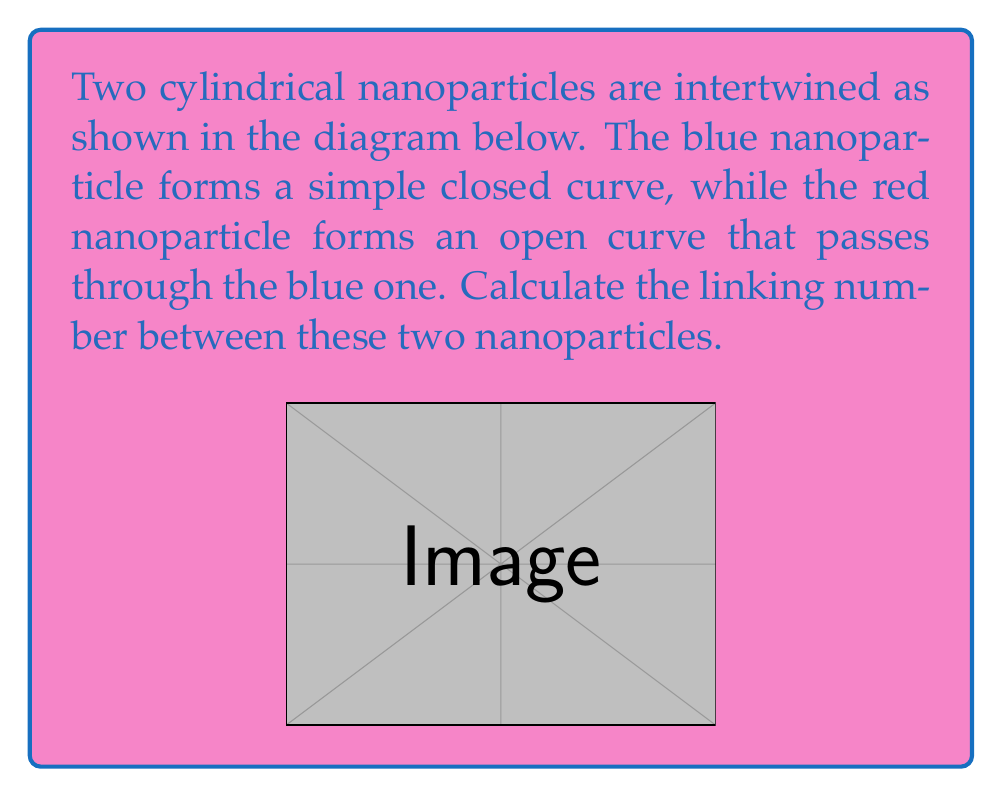Show me your answer to this math problem. To compute the linking number between two intertwined nanoparticles, we need to follow these steps:

1) The linking number is defined as half the sum of signed crossings in a regular projection of the link. In this case, we're looking at a projection onto the xy-plane.

2) In our projection, we see that the red nanoparticle (open curve) passes through the blue nanoparticle (closed curve) twice.

3) We need to determine the sign of each crossing. The sign is positive if the overcrossing strand can be rotated counterclockwise to align with the undercrossing strand, and negative otherwise.

4) Let's examine each crossing:
   a) At the left crossing, the red strand goes over the blue strand. Rotating the red strand counterclockwise aligns it with the blue strand. This is a positive crossing.
   b) At the right crossing, the red strand goes under the blue strand. Rotating the blue strand counterclockwise aligns it with the red strand. This is also a positive crossing.

5) Both crossings are positive, so our sum of signed crossings is 2.

6) The linking number is half this sum:

   $$\text{Linking Number} = \frac{1}{2} \sum \text{(Signed Crossings)} = \frac{1}{2} (2) = 1$$

Therefore, the linking number between these two intertwined nanoparticles is 1.
Answer: 1 